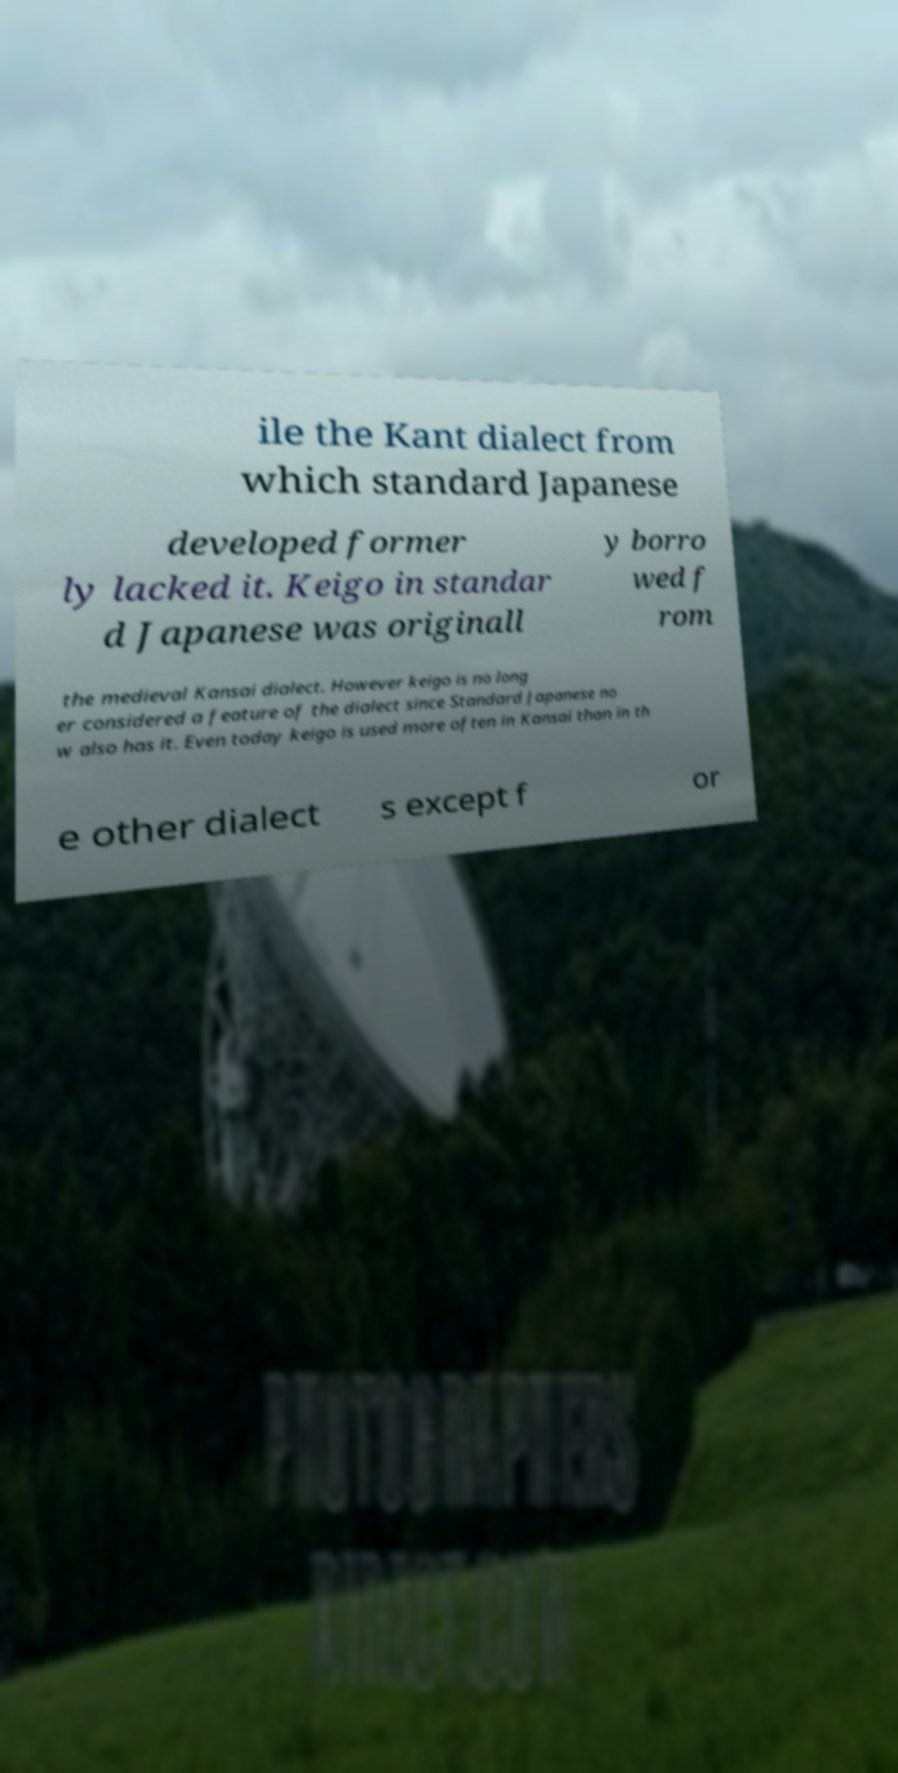Could you extract and type out the text from this image? ile the Kant dialect from which standard Japanese developed former ly lacked it. Keigo in standar d Japanese was originall y borro wed f rom the medieval Kansai dialect. However keigo is no long er considered a feature of the dialect since Standard Japanese no w also has it. Even today keigo is used more often in Kansai than in th e other dialect s except f or 